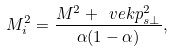<formula> <loc_0><loc_0><loc_500><loc_500>M _ { i } ^ { 2 } = \frac { M ^ { 2 } + \ v e k p _ { s \perp } ^ { 2 } } { \alpha ( 1 - \alpha ) } ,</formula> 